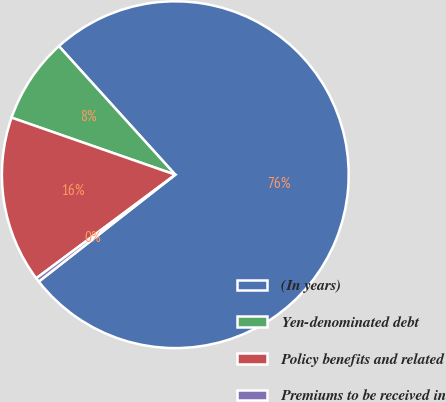Convert chart. <chart><loc_0><loc_0><loc_500><loc_500><pie_chart><fcel>(In years)<fcel>Yen-denominated debt<fcel>Policy benefits and related<fcel>Premiums to be received in<nl><fcel>76.14%<fcel>7.95%<fcel>15.53%<fcel>0.38%<nl></chart> 